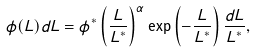Convert formula to latex. <formula><loc_0><loc_0><loc_500><loc_500>\phi ( L ) d L = \phi ^ { * } \left ( \frac { L } { L ^ { * } } \right ) ^ { \alpha } \exp \left ( - \frac { L } { L ^ { * } } \right ) \frac { d L } { L ^ { * } } ,</formula> 